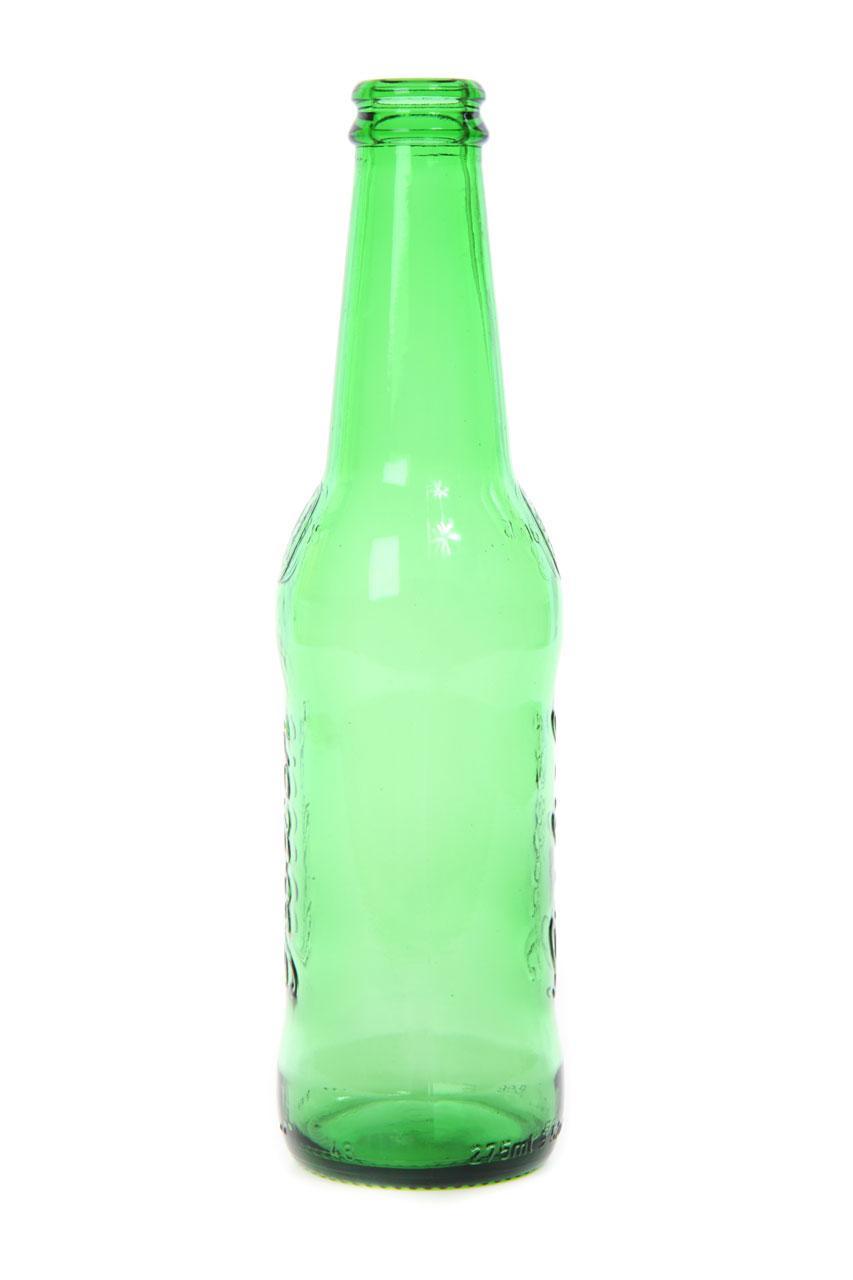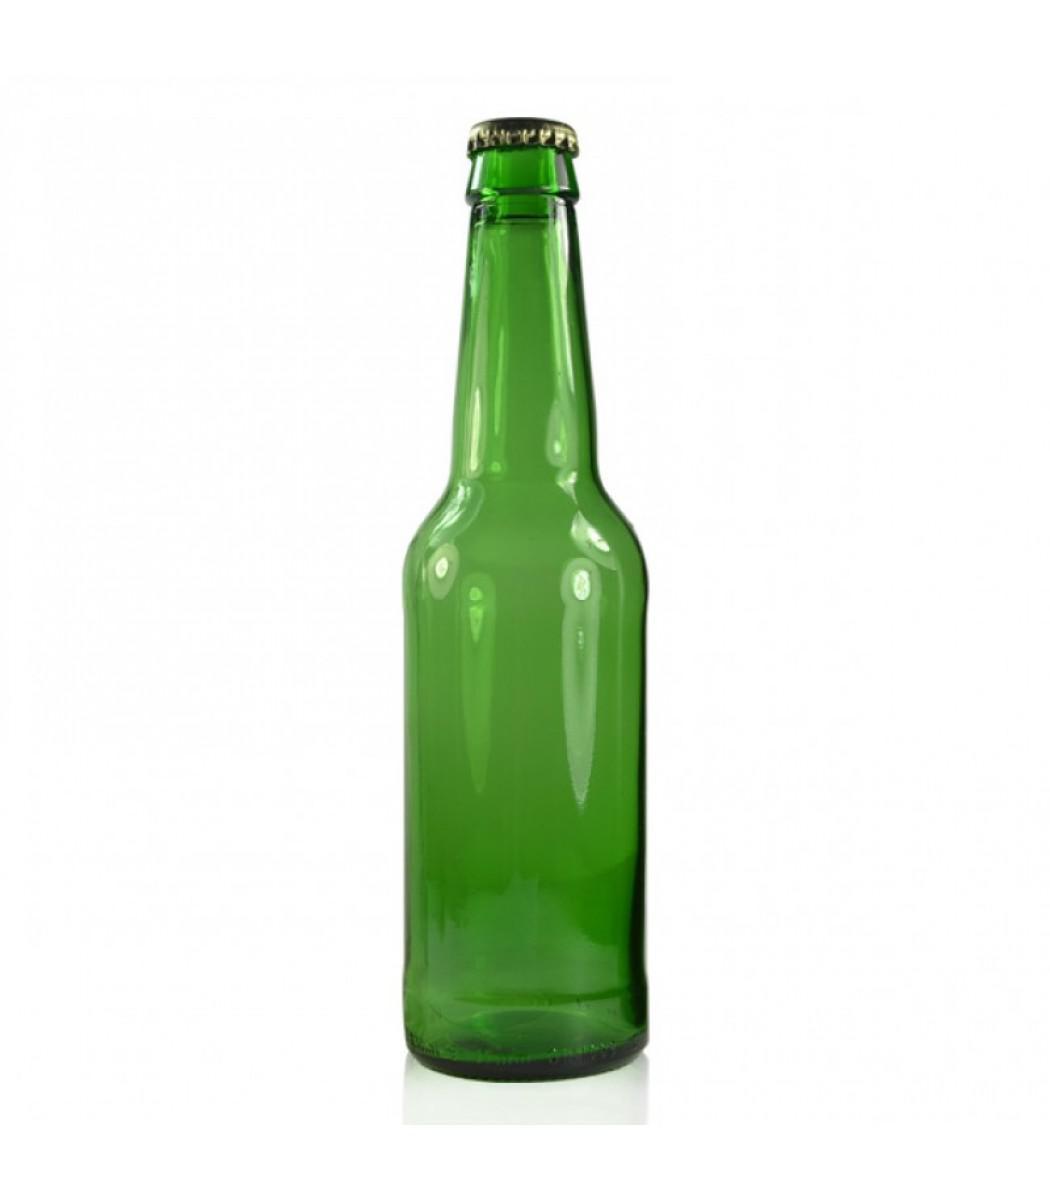The first image is the image on the left, the second image is the image on the right. Examine the images to the left and right. Is the description "There are no more than six glass bottles" accurate? Answer yes or no. Yes. 